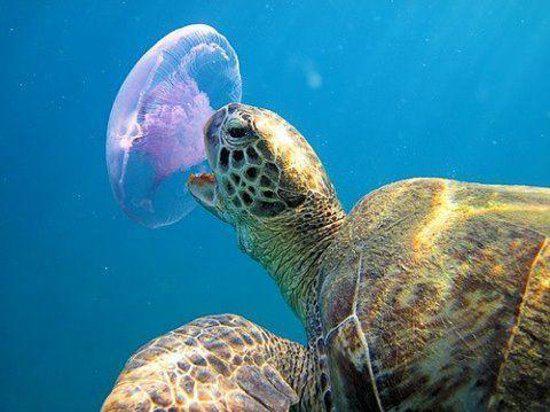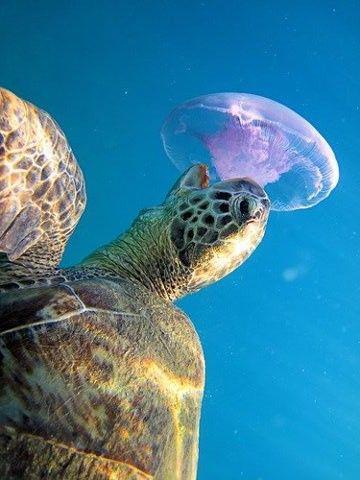The first image is the image on the left, the second image is the image on the right. For the images displayed, is the sentence "a turtle is taking a bite of a pink jellyfish" factually correct? Answer yes or no. Yes. The first image is the image on the left, the second image is the image on the right. Given the left and right images, does the statement "There are no more than six fish swimming next to a turtle." hold true? Answer yes or no. No. 